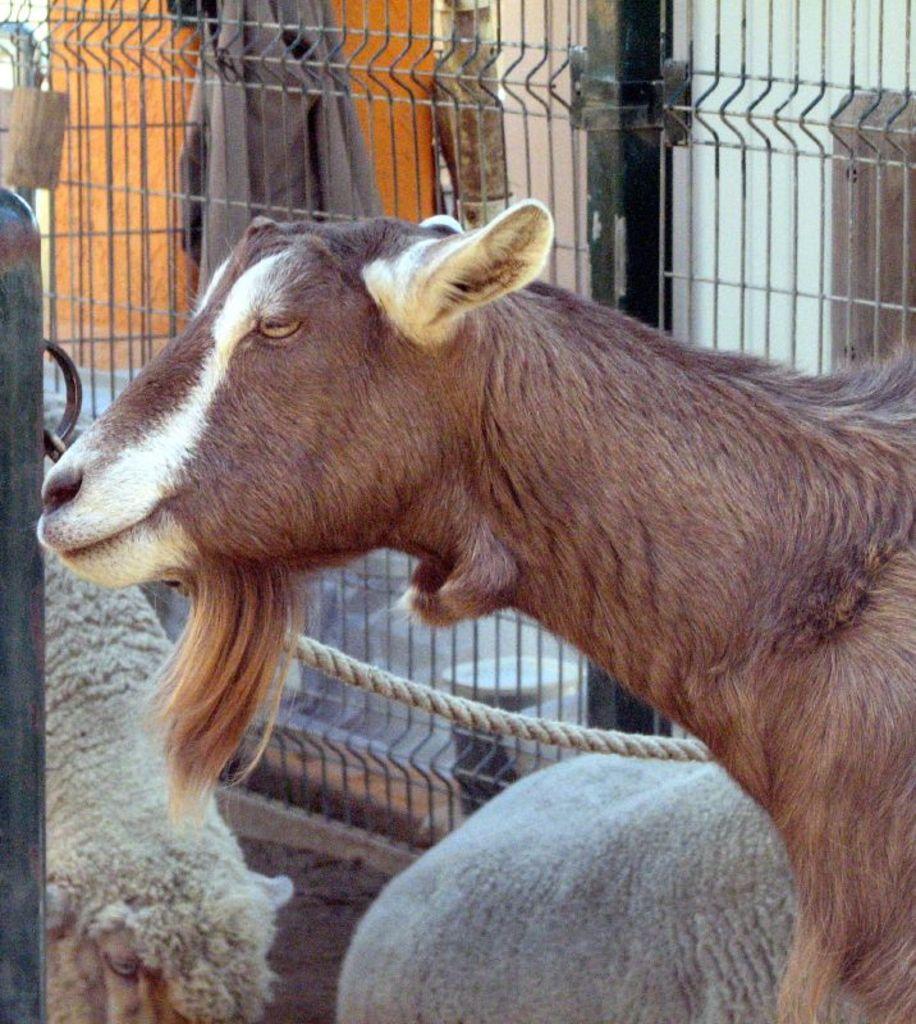Describe this image in one or two sentences. This image consists of a goat and sheep. In the background, we can see a fence made up of metal. And there is a cloth. 